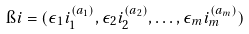Convert formula to latex. <formula><loc_0><loc_0><loc_500><loc_500>\i i = ( \epsilon _ { 1 } i _ { 1 } ^ { ( a _ { 1 } ) } , \epsilon _ { 2 } i _ { 2 } ^ { ( a _ { 2 } ) } , \dots , \epsilon _ { m } i _ { m } ^ { ( a _ { m } ) } )</formula> 